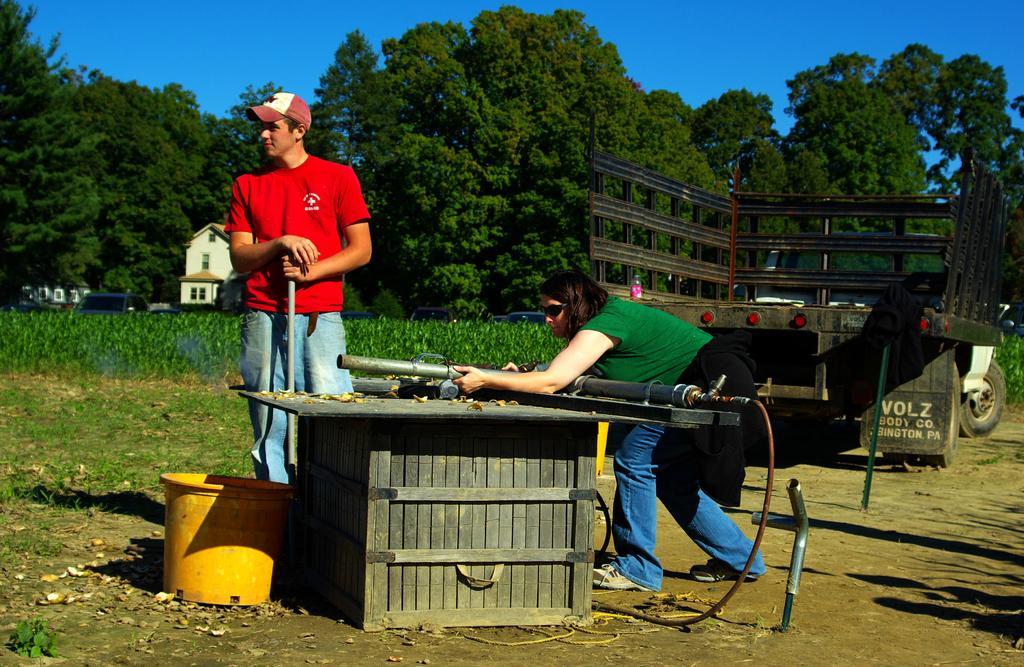Can you describe this image briefly? In this picture there are two people holding rods and we can see objects on the wooden box, basket, pipe, leaves and pole. We can see vehicle on the ground, grass and plants. In the background of the image we can see houses, trees, vehicles and sky in blue color. 